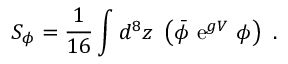Convert formula to latex. <formula><loc_0><loc_0><loc_500><loc_500>S _ { \phi } = \frac { 1 } { 1 6 } \int d ^ { 8 } z \ \left ( { \bar { \phi } } \ { \mathrm e } ^ { g V } \ \phi \right ) \ .</formula> 